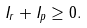<formula> <loc_0><loc_0><loc_500><loc_500>I _ { r } + I _ { p } \geq 0 .</formula> 